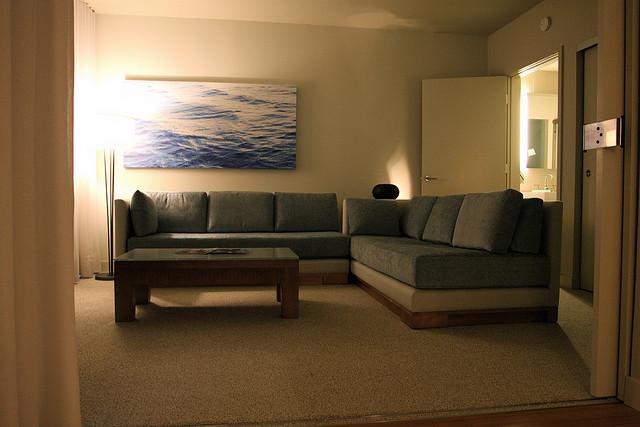Is the lamp on?
Concise answer only. Yes. How many pillows are on both couches?
Answer briefly. 8. Is the door open?
Keep it brief. Yes. Where are the gray pillows?
Keep it brief. Couch. 